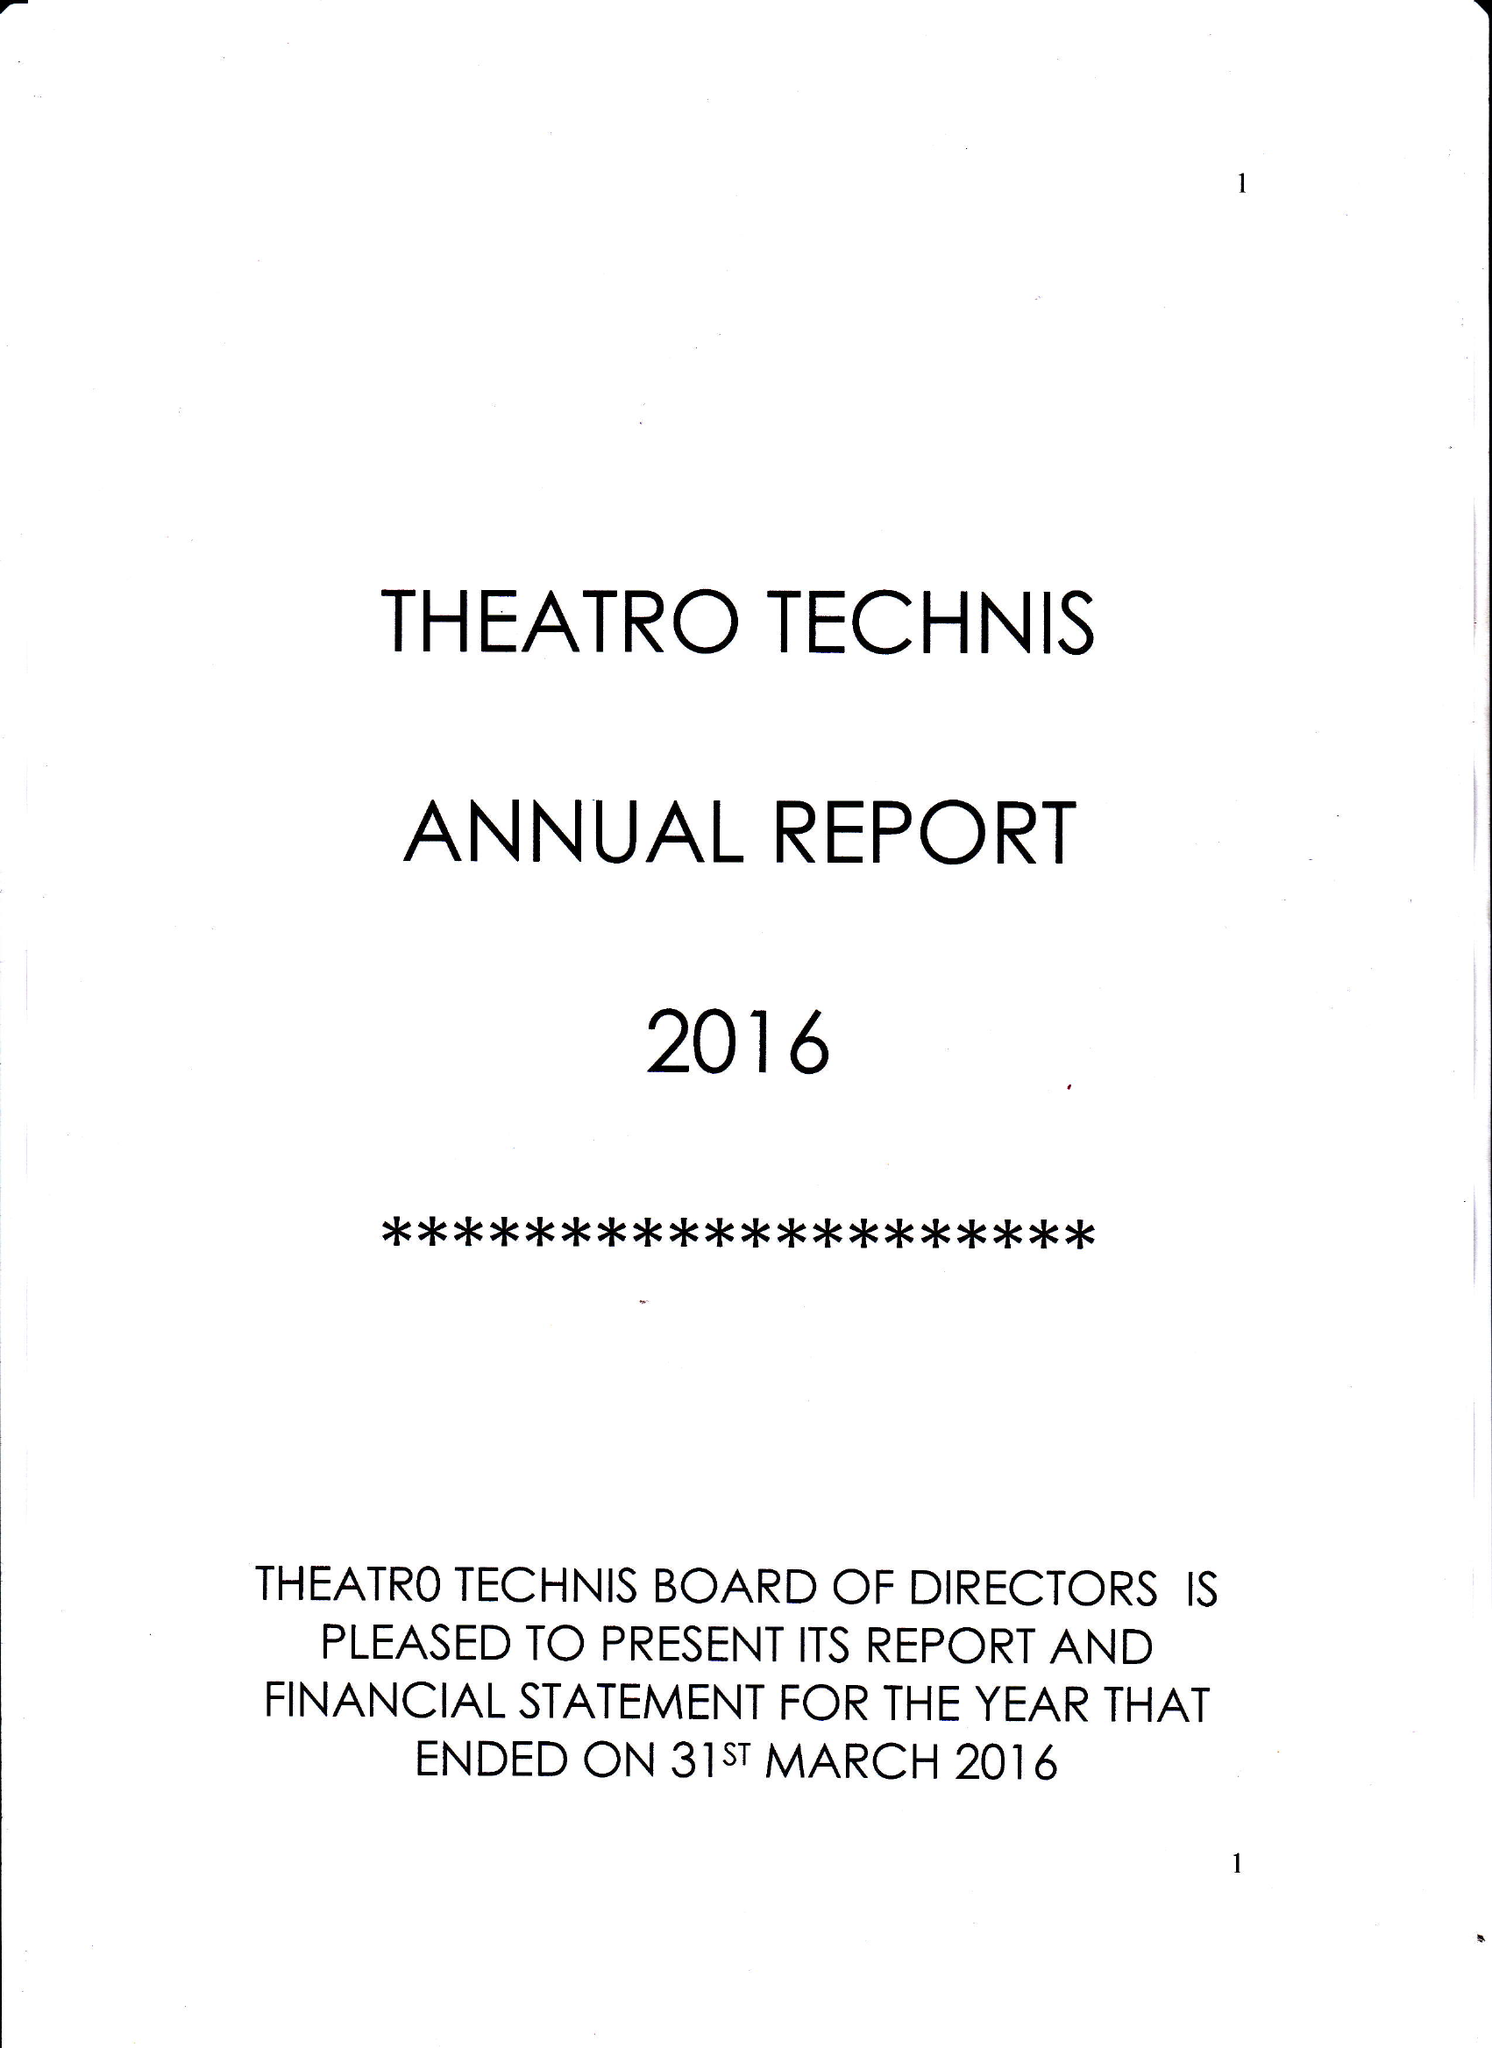What is the value for the charity_name?
Answer the question using a single word or phrase. Theatro Technis Company Ltd. 